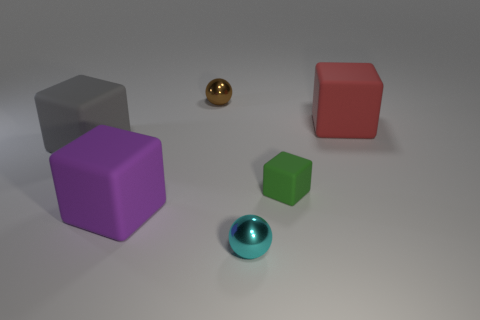Subtract all purple cubes. How many cubes are left? 3 Subtract all big rubber cubes. How many cubes are left? 1 Subtract all blue cubes. Subtract all yellow spheres. How many cubes are left? 4 Add 2 large red objects. How many objects exist? 8 Subtract all spheres. How many objects are left? 4 Subtract all small purple cubes. Subtract all large purple rubber objects. How many objects are left? 5 Add 5 tiny brown balls. How many tiny brown balls are left? 6 Add 6 green metal blocks. How many green metal blocks exist? 6 Subtract 0 cyan cylinders. How many objects are left? 6 